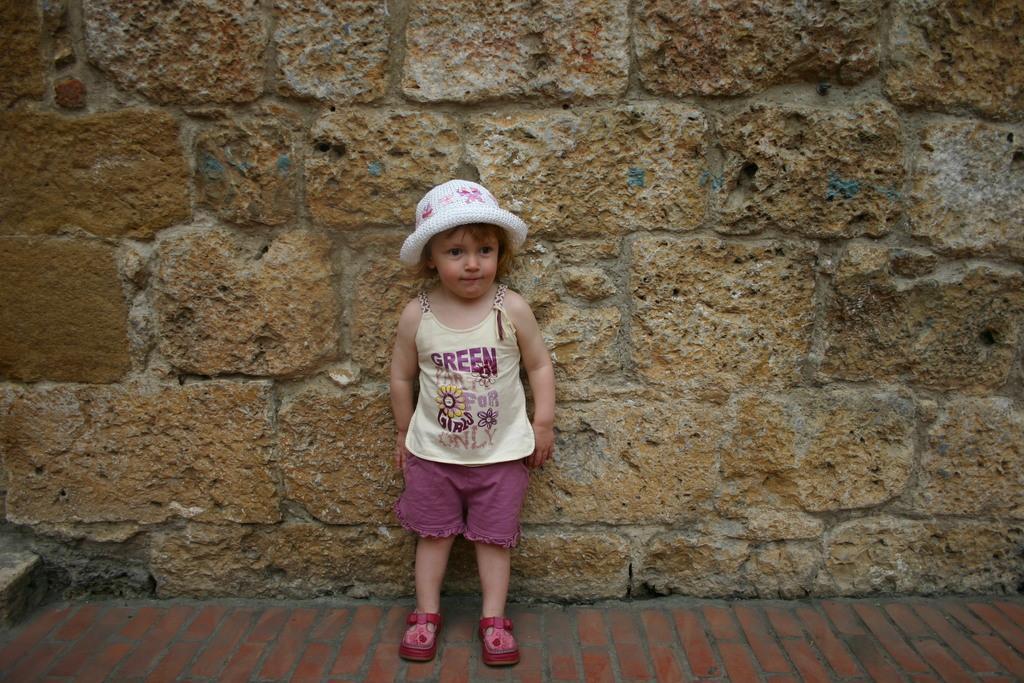Describe this image in one or two sentences. In this picture there is a girl who is wearing hat, t-shirt, short and shoes. She is standing near to the wall. At the bottom I can see the brick floor. 